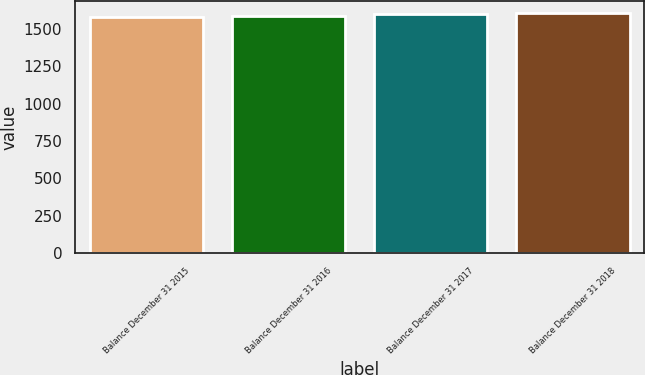Convert chart. <chart><loc_0><loc_0><loc_500><loc_500><bar_chart><fcel>Balance December 31 2015<fcel>Balance December 31 2016<fcel>Balance December 31 2017<fcel>Balance December 31 2018<nl><fcel>1577<fcel>1586<fcel>1598<fcel>1605<nl></chart> 